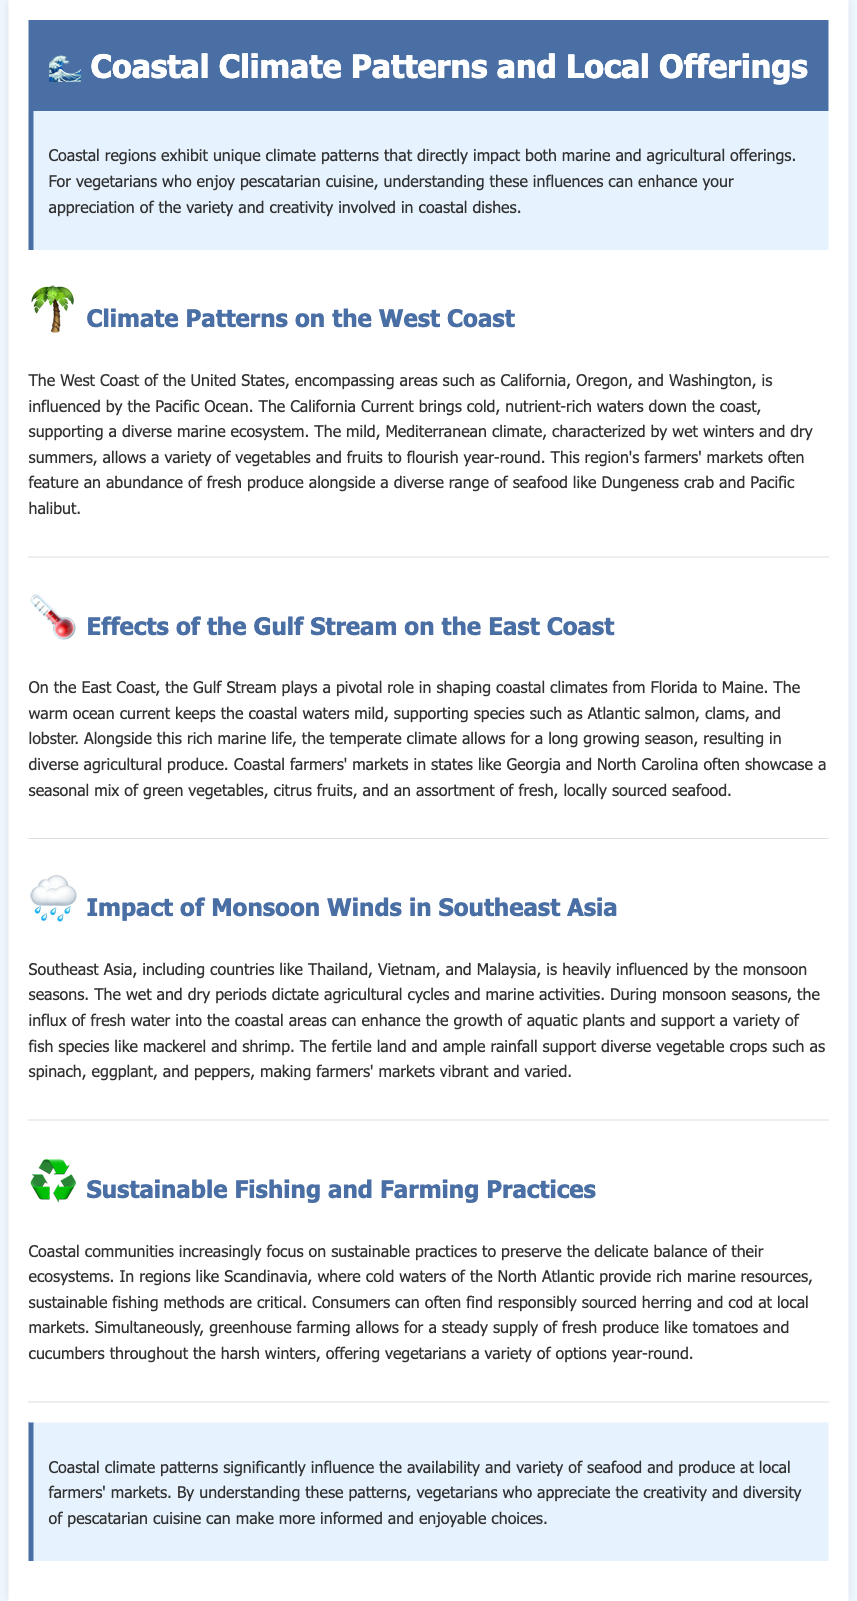What is the title of the document? The title is clearly stated in the header section of the document.
Answer: Coastal Climate and Local Offerings Which ocean influences the West Coast climate? The document specifies the ocean that affects the West Coast climate.
Answer: Pacific Ocean What seafood is commonly found in West Coast farmers' markets? The text identifies specific seafood types featured in West Coast markets.
Answer: Dungeness crab and Pacific halibut What is the role of the Gulf Stream? The document highlights the importance of the Gulf Stream along the East Coast climate.
Answer: Shapes coastal climates Which fish species is mentioned for Southeast Asia? The document lists specific fish species relevant to the Southeast Asian coastal region.
Answer: Mackerel What type of climate is found on the East Coast? The document describes the climate conditions typical of the East Coast.
Answer: Temperate climate How do sustainable practices relate to consumers? The document explains the relationship between sustainable fishing methods and consumers.
Answer: Responsibly sourced seafood What crops are grown during monsoon seasons? The text provides examples of crops that thrive during these seasons in Southeast Asia.
Answer: Spinach, eggplant, and peppers 